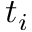Convert formula to latex. <formula><loc_0><loc_0><loc_500><loc_500>t _ { i }</formula> 